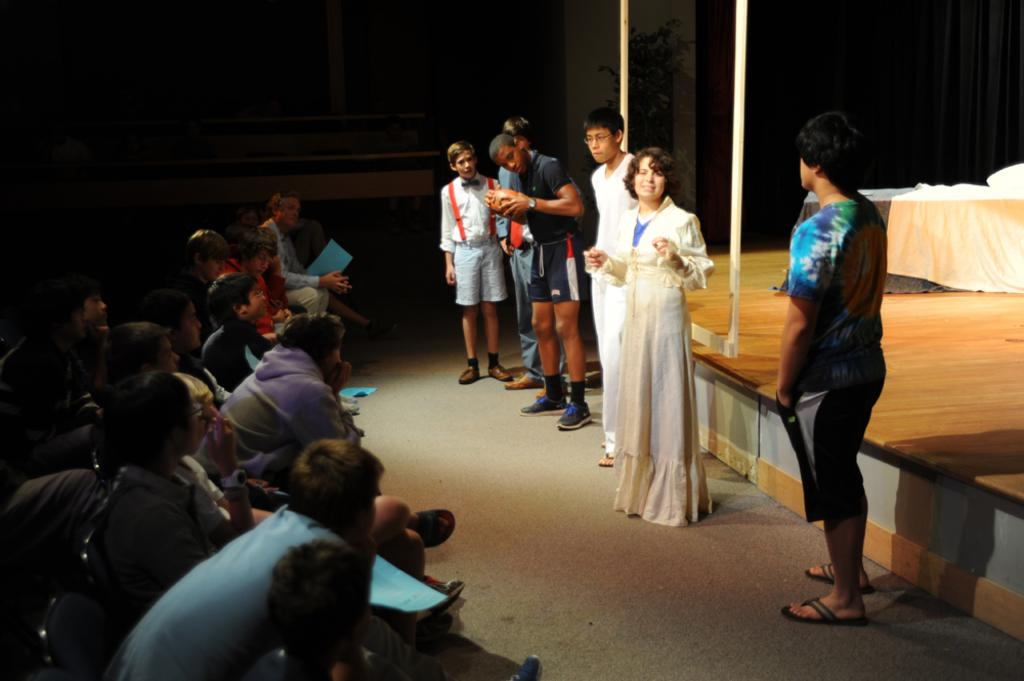Where are the people located in the image? People are seated on the left side of the image. What are some people doing in the image? Some people are standing in the image. What can be seen on the right side of the image? There is a stage on the right side of the image. Can you describe the stage in the image? The stage has a frame and a table on it. What is present at the back of the stage? There is a plant at the back of the stage. What caption is written on the notebook held by the doll in the image? There is no doll or notebook present in the image. 